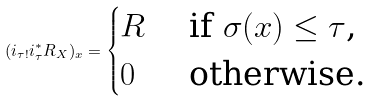Convert formula to latex. <formula><loc_0><loc_0><loc_500><loc_500>( i _ { \tau ! } i _ { \tau } ^ { * } R _ { X } ) _ { x } = \begin{cases} R & \text { if $\sigma(x) \leq \tau$,} \\ 0 & \text { otherwise.} \end{cases}</formula> 